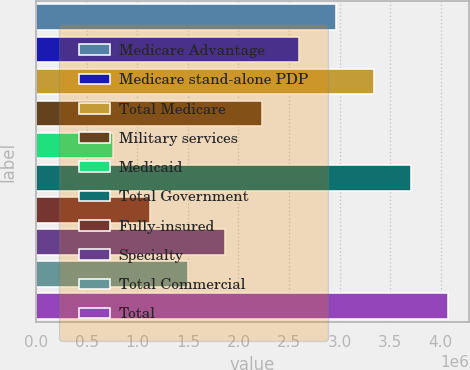Convert chart to OTSL. <chart><loc_0><loc_0><loc_500><loc_500><bar_chart><fcel>Medicare Advantage<fcel>Medicare stand-alone PDP<fcel>Total Medicare<fcel>Military services<fcel>Medicaid<fcel>Total Government<fcel>Fully-insured<fcel>Specialty<fcel>Total Commercial<fcel>Total<nl><fcel>2.96898e+06<fcel>2.60088e+06<fcel>3.33707e+06<fcel>2.23279e+06<fcel>760407<fcel>3.70516e+06<fcel>1.1285e+06<fcel>1.86469e+06<fcel>1.4966e+06<fcel>4.07326e+06<nl></chart> 